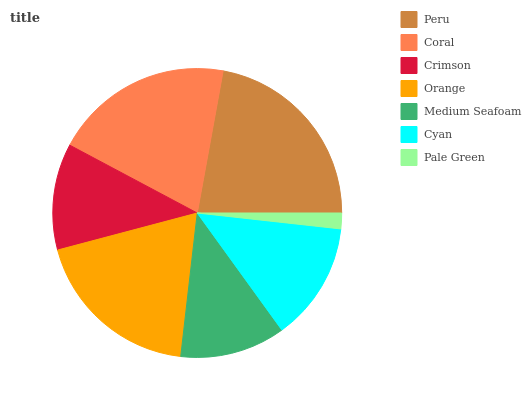Is Pale Green the minimum?
Answer yes or no. Yes. Is Peru the maximum?
Answer yes or no. Yes. Is Coral the minimum?
Answer yes or no. No. Is Coral the maximum?
Answer yes or no. No. Is Peru greater than Coral?
Answer yes or no. Yes. Is Coral less than Peru?
Answer yes or no. Yes. Is Coral greater than Peru?
Answer yes or no. No. Is Peru less than Coral?
Answer yes or no. No. Is Cyan the high median?
Answer yes or no. Yes. Is Cyan the low median?
Answer yes or no. Yes. Is Orange the high median?
Answer yes or no. No. Is Peru the low median?
Answer yes or no. No. 